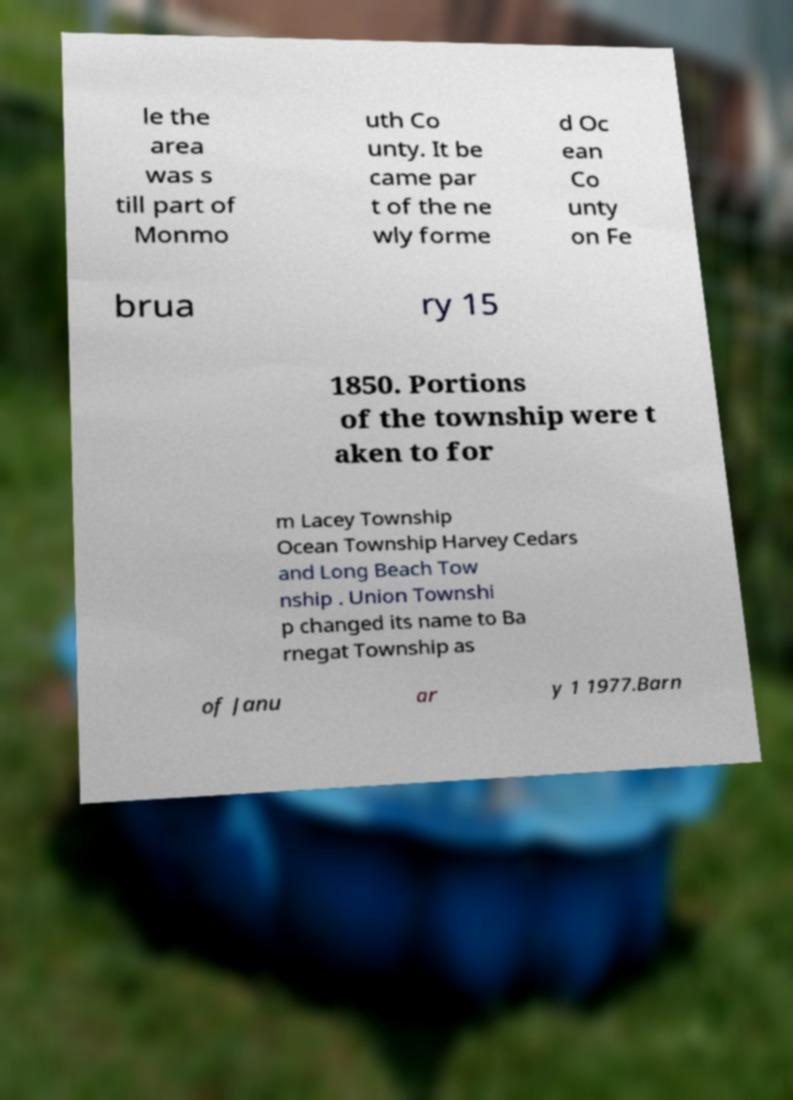Can you accurately transcribe the text from the provided image for me? le the area was s till part of Monmo uth Co unty. It be came par t of the ne wly forme d Oc ean Co unty on Fe brua ry 15 1850. Portions of the township were t aken to for m Lacey Township Ocean Township Harvey Cedars and Long Beach Tow nship . Union Townshi p changed its name to Ba rnegat Township as of Janu ar y 1 1977.Barn 